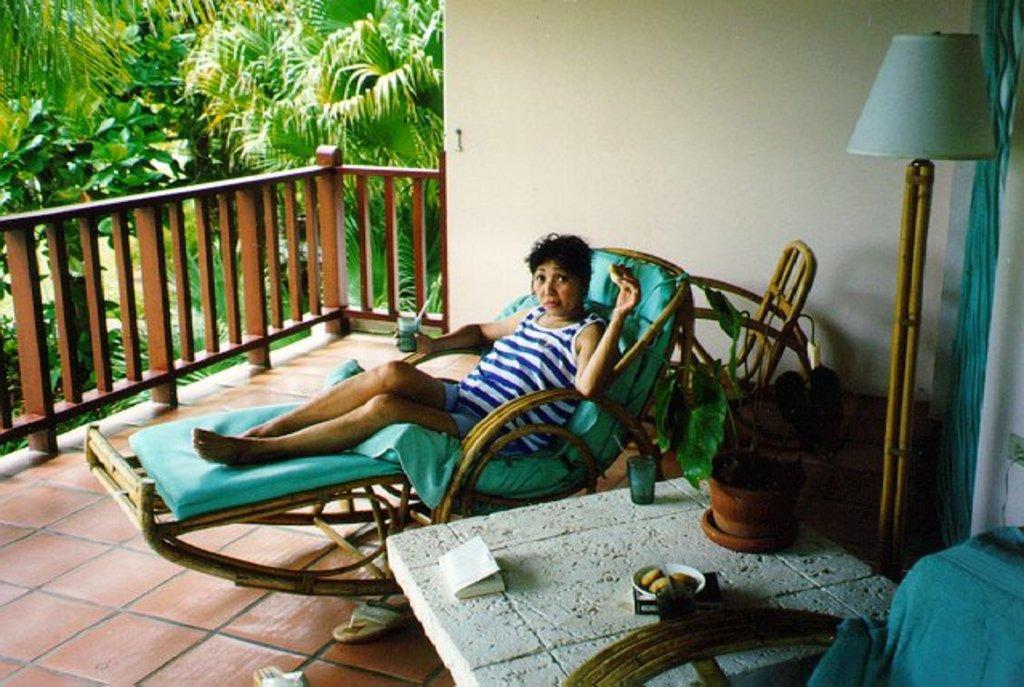How would you summarize this image in a sentence or two? In the center of the image we can see one person is sitting on the relaxing chair and she is holding some objects. And we can see one table, glass, chair, lamp, book and some objects. In the background there is a wall, trees and fence. 